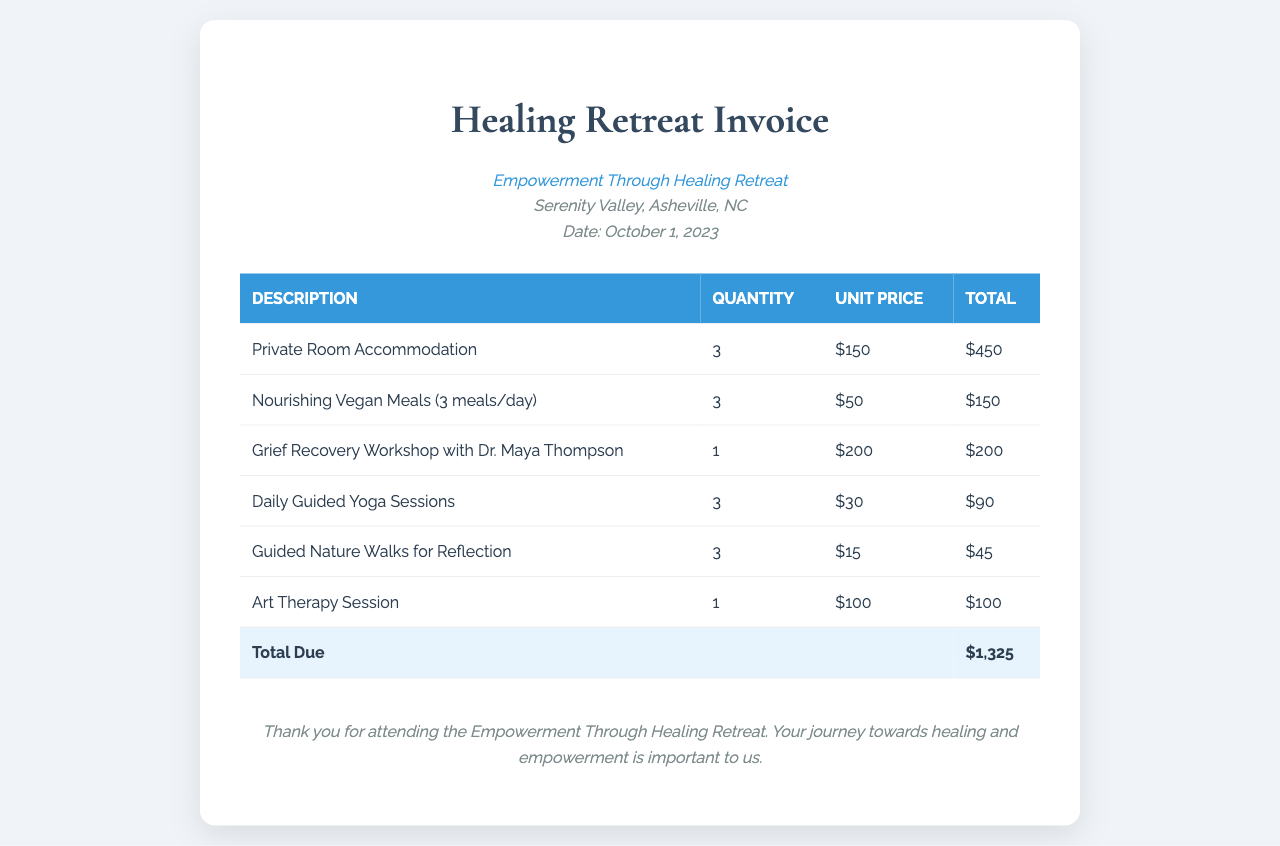what is the invoice title? The title of the invoice is prominently displayed at the top of the document, indicating it is a Healing Retreat Invoice.
Answer: Healing Retreat Invoice what is the date of the retreat? The date is noted in the retreat information section of the document, which shows the event Date as October 1, 2023.
Answer: October 1, 2023 how much does a private room accommodation cost per unit? The unit price for private room accommodation is listed in the invoice table, specifically showing $150.
Answer: $150 what is the total amount due on the invoice? The total due amount is summarized at the bottom of the table, which states the total as $1,325.
Answer: $1,325 who conducted the grief recovery workshop? The name of the person conducting the workshop is mentioned in the description of the service, listed as Dr. Maya Thompson.
Answer: Dr. Maya Thompson how many daily guided yoga sessions are included? The number of sessions for daily guided yoga is detailed in the invoice, showing a quantity of 3.
Answer: 3 what type of meals are provided during the retreat? The type of meals offered is specified in the invoice, indicating that they are nourishing vegan meals.
Answer: Nourishing Vegan Meals what is the total cost for guided nature walks for reflection? The total cost for this service is included in the invoice, calculated as $15 per unit for 3 units, totaling $45.
Answer: $45 how many activities related to grief recovery are listed on the invoice? The number of activities related to grief recovery is found by counting specific services in the table, totaling 4 activities.
Answer: 4 